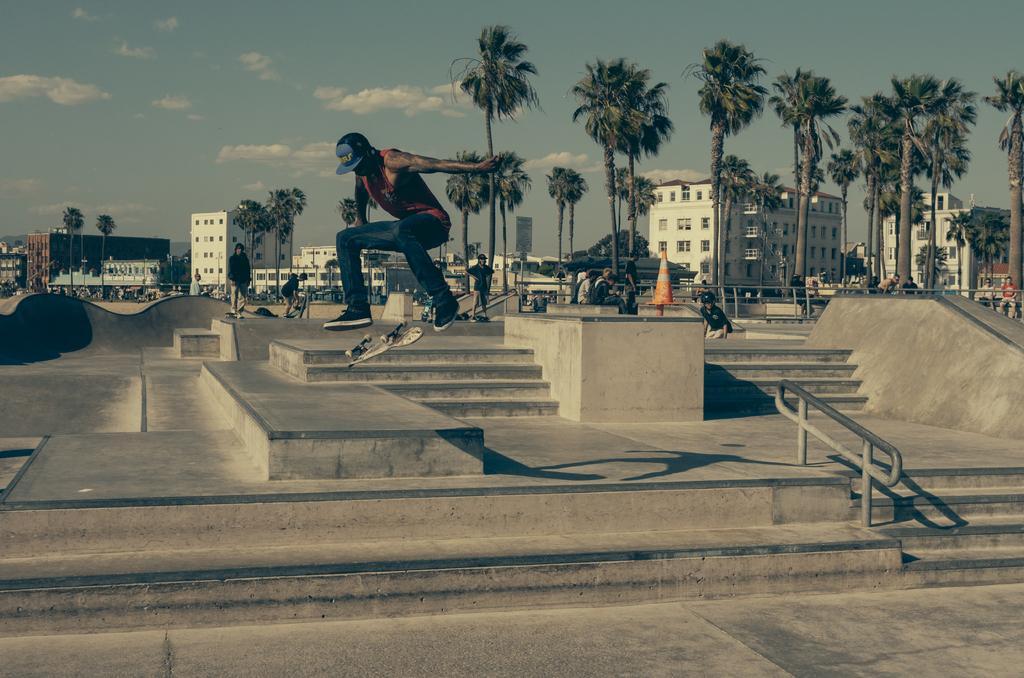In one or two sentences, can you explain what this image depicts? A person and skateboard are in air. Background there are people, steps, buildings, traffic cone and trees. These are clouds. 